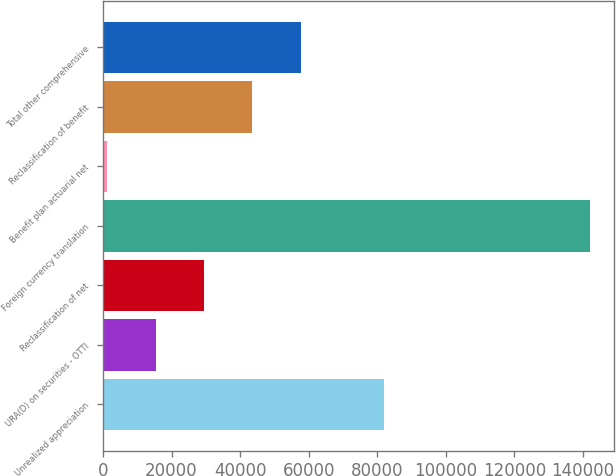<chart> <loc_0><loc_0><loc_500><loc_500><bar_chart><fcel>Unrealized appreciation<fcel>URA(D) on securities - OTTI<fcel>Reclassification of net<fcel>Foreign currency translation<fcel>Benefit plan actuarial net<fcel>Reclassification of benefit<fcel>Total other comprehensive<nl><fcel>81915<fcel>15375.4<fcel>29450.8<fcel>142054<fcel>1300<fcel>43526.2<fcel>57601.6<nl></chart> 